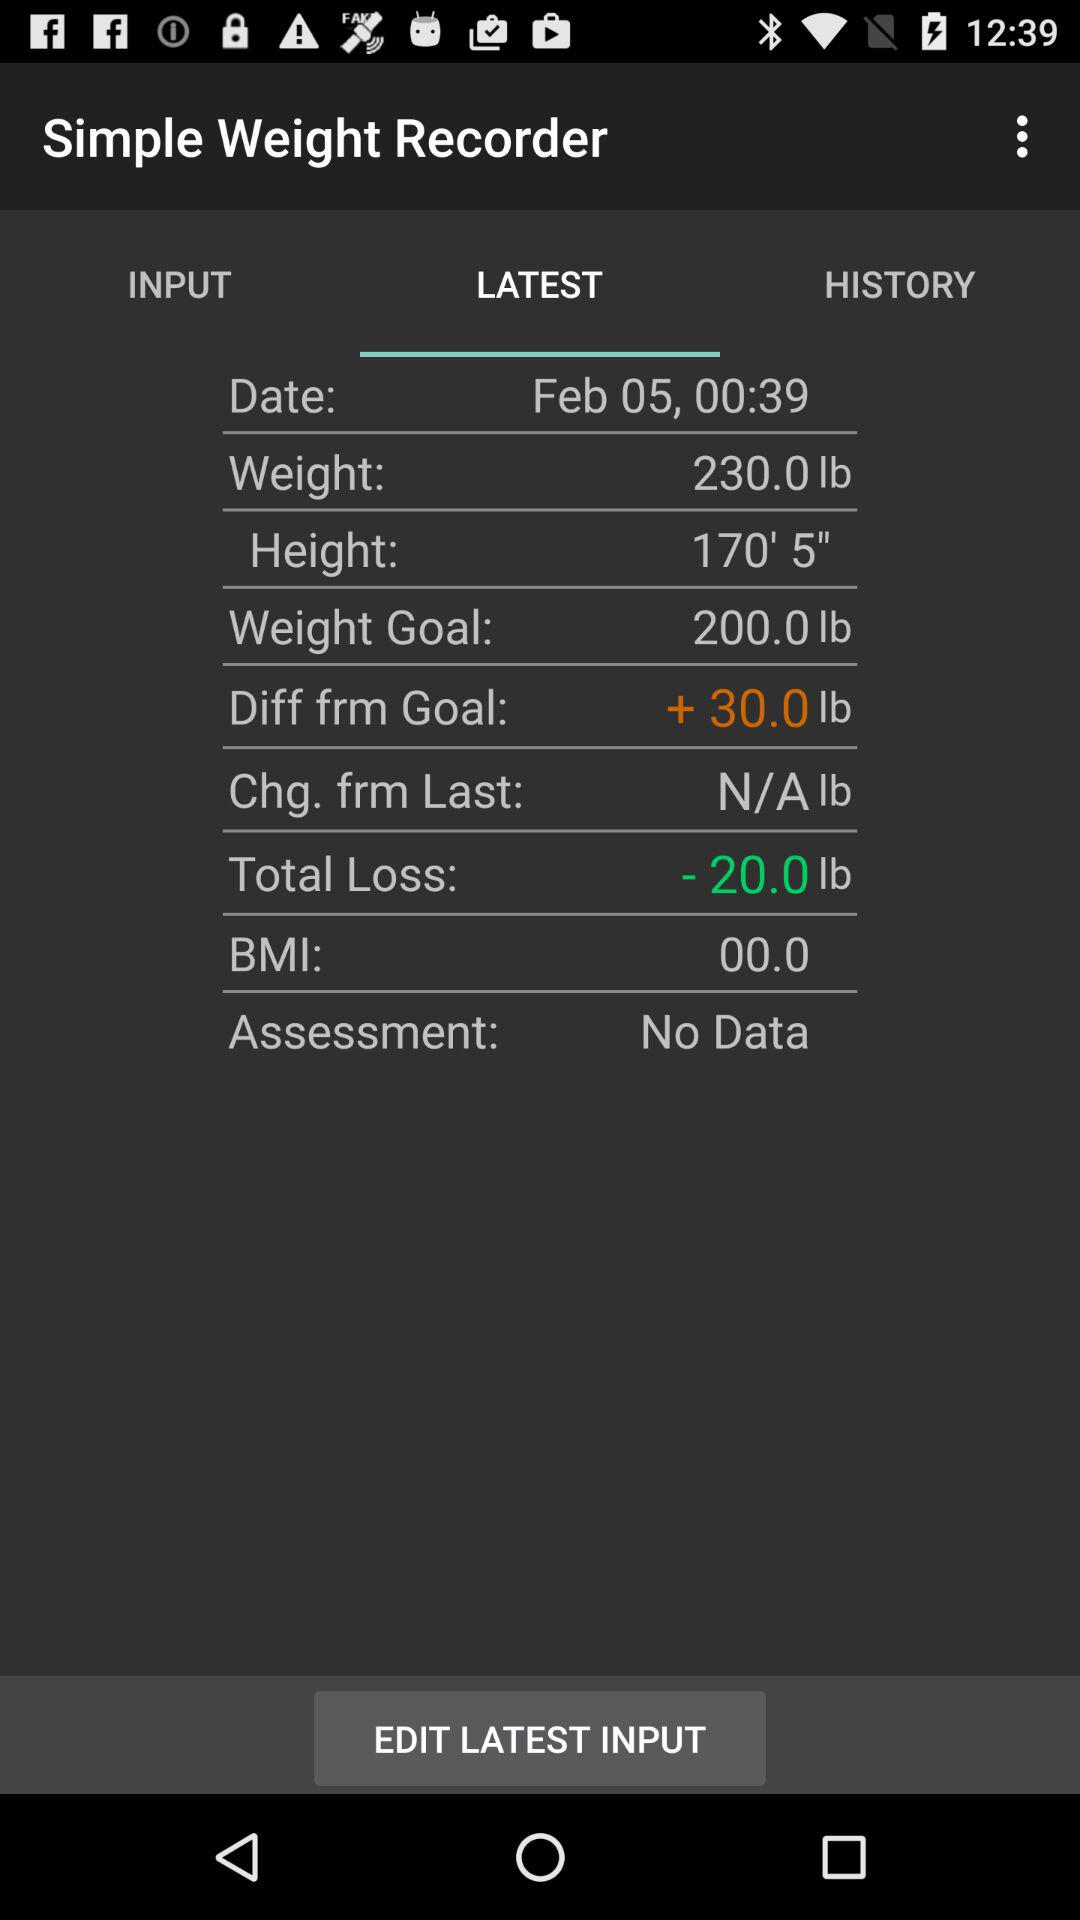What is the difference between the weight goal and the current weight?
Answer the question using a single word or phrase. 30.0 lb 